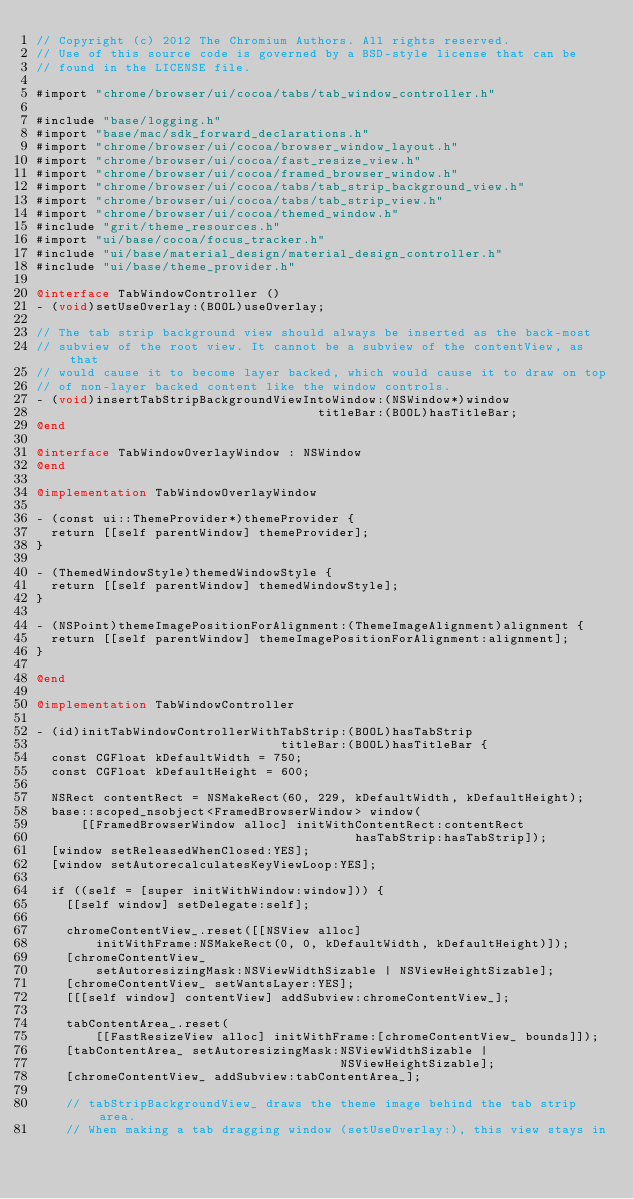Convert code to text. <code><loc_0><loc_0><loc_500><loc_500><_ObjectiveC_>// Copyright (c) 2012 The Chromium Authors. All rights reserved.
// Use of this source code is governed by a BSD-style license that can be
// found in the LICENSE file.

#import "chrome/browser/ui/cocoa/tabs/tab_window_controller.h"

#include "base/logging.h"
#import "base/mac/sdk_forward_declarations.h"
#import "chrome/browser/ui/cocoa/browser_window_layout.h"
#import "chrome/browser/ui/cocoa/fast_resize_view.h"
#import "chrome/browser/ui/cocoa/framed_browser_window.h"
#import "chrome/browser/ui/cocoa/tabs/tab_strip_background_view.h"
#import "chrome/browser/ui/cocoa/tabs/tab_strip_view.h"
#import "chrome/browser/ui/cocoa/themed_window.h"
#include "grit/theme_resources.h"
#import "ui/base/cocoa/focus_tracker.h"
#include "ui/base/material_design/material_design_controller.h"
#include "ui/base/theme_provider.h"

@interface TabWindowController ()
- (void)setUseOverlay:(BOOL)useOverlay;

// The tab strip background view should always be inserted as the back-most
// subview of the root view. It cannot be a subview of the contentView, as that
// would cause it to become layer backed, which would cause it to draw on top
// of non-layer backed content like the window controls.
- (void)insertTabStripBackgroundViewIntoWindow:(NSWindow*)window
                                      titleBar:(BOOL)hasTitleBar;
@end

@interface TabWindowOverlayWindow : NSWindow
@end

@implementation TabWindowOverlayWindow

- (const ui::ThemeProvider*)themeProvider {
  return [[self parentWindow] themeProvider];
}

- (ThemedWindowStyle)themedWindowStyle {
  return [[self parentWindow] themedWindowStyle];
}

- (NSPoint)themeImagePositionForAlignment:(ThemeImageAlignment)alignment {
  return [[self parentWindow] themeImagePositionForAlignment:alignment];
}

@end

@implementation TabWindowController

- (id)initTabWindowControllerWithTabStrip:(BOOL)hasTabStrip
                                 titleBar:(BOOL)hasTitleBar {
  const CGFloat kDefaultWidth = 750;
  const CGFloat kDefaultHeight = 600;

  NSRect contentRect = NSMakeRect(60, 229, kDefaultWidth, kDefaultHeight);
  base::scoped_nsobject<FramedBrowserWindow> window(
      [[FramedBrowserWindow alloc] initWithContentRect:contentRect
                                           hasTabStrip:hasTabStrip]);
  [window setReleasedWhenClosed:YES];
  [window setAutorecalculatesKeyViewLoop:YES];

  if ((self = [super initWithWindow:window])) {
    [[self window] setDelegate:self];

    chromeContentView_.reset([[NSView alloc]
        initWithFrame:NSMakeRect(0, 0, kDefaultWidth, kDefaultHeight)]);
    [chromeContentView_
        setAutoresizingMask:NSViewWidthSizable | NSViewHeightSizable];
    [chromeContentView_ setWantsLayer:YES];
    [[[self window] contentView] addSubview:chromeContentView_];

    tabContentArea_.reset(
        [[FastResizeView alloc] initWithFrame:[chromeContentView_ bounds]]);
    [tabContentArea_ setAutoresizingMask:NSViewWidthSizable |
                                         NSViewHeightSizable];
    [chromeContentView_ addSubview:tabContentArea_];

    // tabStripBackgroundView_ draws the theme image behind the tab strip area.
    // When making a tab dragging window (setUseOverlay:), this view stays in</code> 